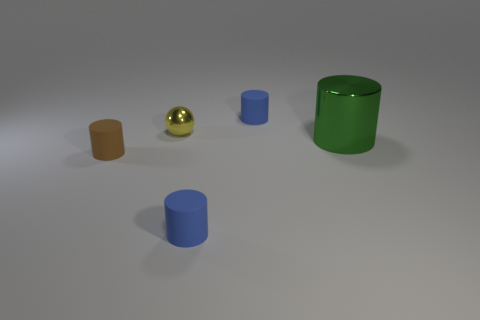Subtract all large cylinders. How many cylinders are left? 3 Add 3 yellow cylinders. How many objects exist? 8 Subtract all red cylinders. Subtract all red balls. How many cylinders are left? 4 Subtract all spheres. How many objects are left? 4 Subtract all small blue metallic balls. Subtract all tiny metal spheres. How many objects are left? 4 Add 4 tiny brown matte cylinders. How many tiny brown matte cylinders are left? 5 Add 4 purple rubber spheres. How many purple rubber spheres exist? 4 Subtract 1 green cylinders. How many objects are left? 4 